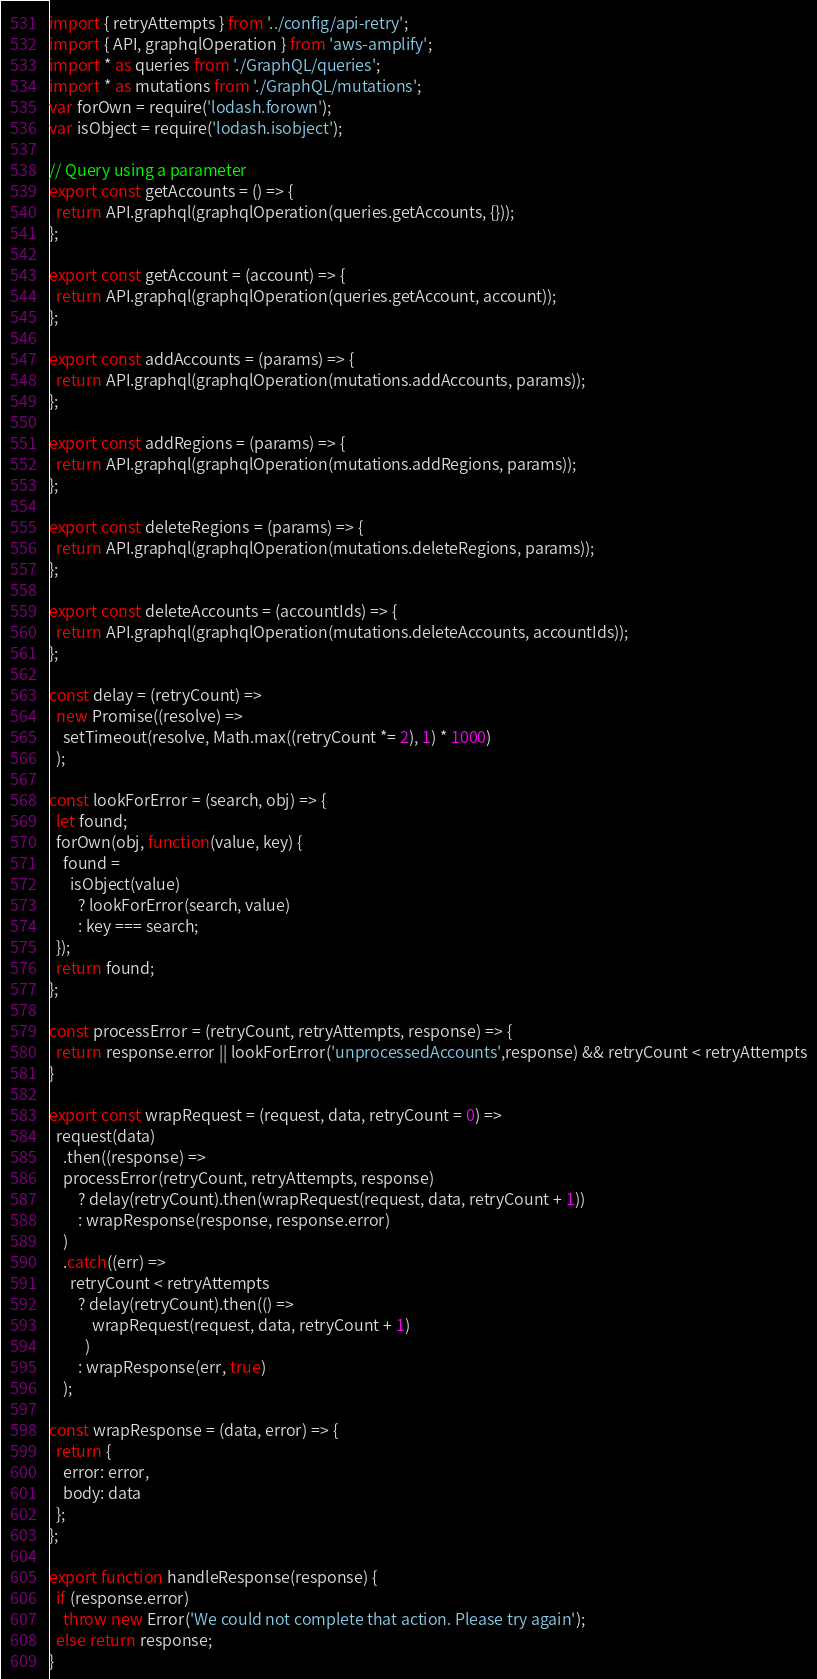Convert code to text. <code><loc_0><loc_0><loc_500><loc_500><_JavaScript_>import { retryAttempts } from '../config/api-retry';
import { API, graphqlOperation } from 'aws-amplify';
import * as queries from './GraphQL/queries';
import * as mutations from './GraphQL/mutations';
var forOwn = require('lodash.forown');
var isObject = require('lodash.isobject');

// Query using a parameter
export const getAccounts = () => {
  return API.graphql(graphqlOperation(queries.getAccounts, {}));
};

export const getAccount = (account) => {
  return API.graphql(graphqlOperation(queries.getAccount, account));
};

export const addAccounts = (params) => {
  return API.graphql(graphqlOperation(mutations.addAccounts, params));
};

export const addRegions = (params) => {
  return API.graphql(graphqlOperation(mutations.addRegions, params));
};

export const deleteRegions = (params) => {
  return API.graphql(graphqlOperation(mutations.deleteRegions, params));
};

export const deleteAccounts = (accountIds) => {
  return API.graphql(graphqlOperation(mutations.deleteAccounts, accountIds));
};

const delay = (retryCount) =>
  new Promise((resolve) =>
    setTimeout(resolve, Math.max((retryCount *= 2), 1) * 1000)
  );

const lookForError = (search, obj) => {
  let found;
  forOwn(obj, function(value, key) {
    found =
      isObject(value)
        ? lookForError(search, value)
        : key === search;
  });
  return found;
};

const processError = (retryCount, retryAttempts, response) => {
  return response.error || lookForError('unprocessedAccounts',response) && retryCount < retryAttempts
}

export const wrapRequest = (request, data, retryCount = 0) =>
  request(data)
    .then((response) =>
    processError(retryCount, retryAttempts, response)
        ? delay(retryCount).then(wrapRequest(request, data, retryCount + 1))
        : wrapResponse(response, response.error)
    )
    .catch((err) =>
      retryCount < retryAttempts
        ? delay(retryCount).then(() =>
            wrapRequest(request, data, retryCount + 1)
          )
        : wrapResponse(err, true)
    );

const wrapResponse = (data, error) => {
  return {
    error: error,
    body: data
  };
};

export function handleResponse(response) {
  if (response.error)
    throw new Error('We could not complete that action. Please try again');
  else return response;
}
</code> 